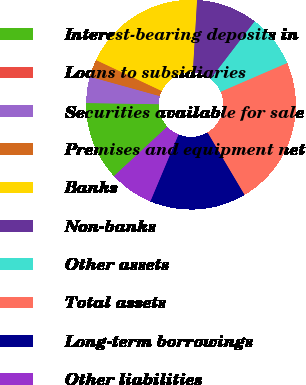<chart> <loc_0><loc_0><loc_500><loc_500><pie_chart><fcel>Interest-bearing deposits in<fcel>Loans to subsidiaries<fcel>Securities available for sale<fcel>Premises and equipment net<fcel>Banks<fcel>Non-banks<fcel>Other assets<fcel>Total assets<fcel>Long-term borrowings<fcel>Other liabilities<nl><fcel>12.16%<fcel>0.0%<fcel>4.05%<fcel>2.7%<fcel>18.92%<fcel>9.46%<fcel>8.11%<fcel>22.97%<fcel>14.86%<fcel>6.76%<nl></chart> 